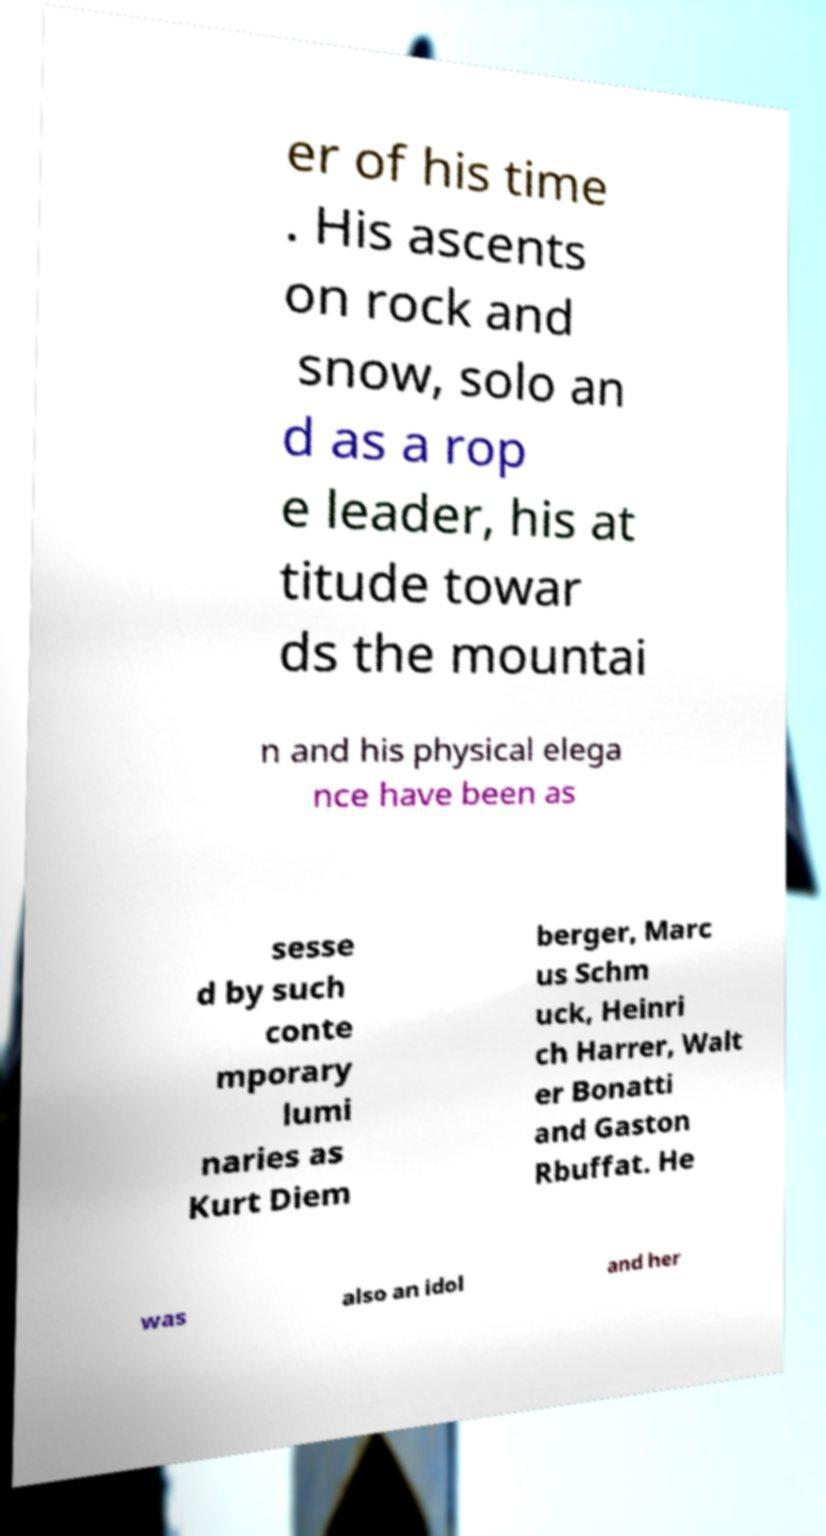Please identify and transcribe the text found in this image. er of his time . His ascents on rock and snow, solo an d as a rop e leader, his at titude towar ds the mountai n and his physical elega nce have been as sesse d by such conte mporary lumi naries as Kurt Diem berger, Marc us Schm uck, Heinri ch Harrer, Walt er Bonatti and Gaston Rbuffat. He was also an idol and her 